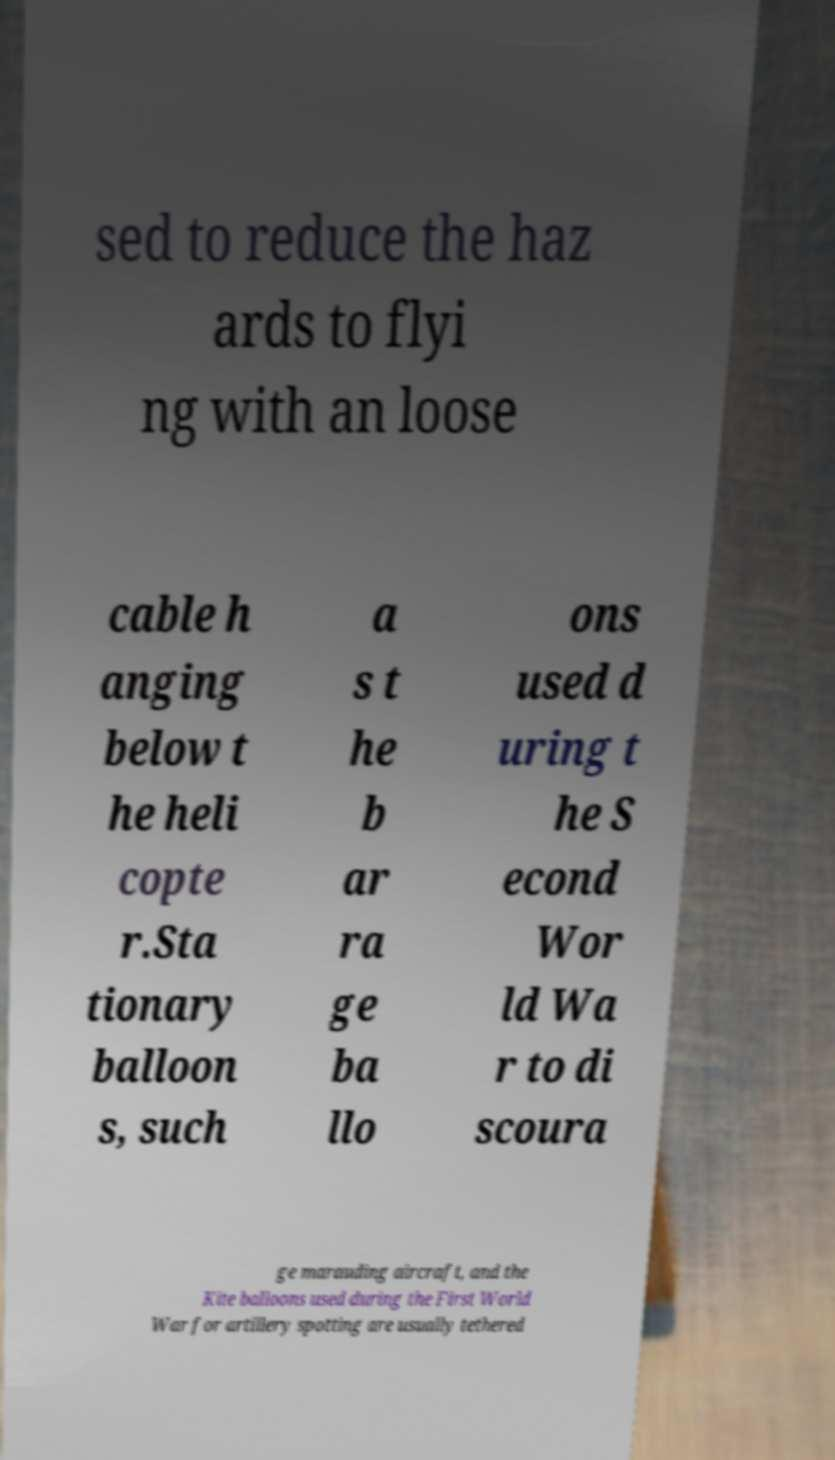Could you extract and type out the text from this image? sed to reduce the haz ards to flyi ng with an loose cable h anging below t he heli copte r.Sta tionary balloon s, such a s t he b ar ra ge ba llo ons used d uring t he S econd Wor ld Wa r to di scoura ge marauding aircraft, and the Kite balloons used during the First World War for artillery spotting are usually tethered 